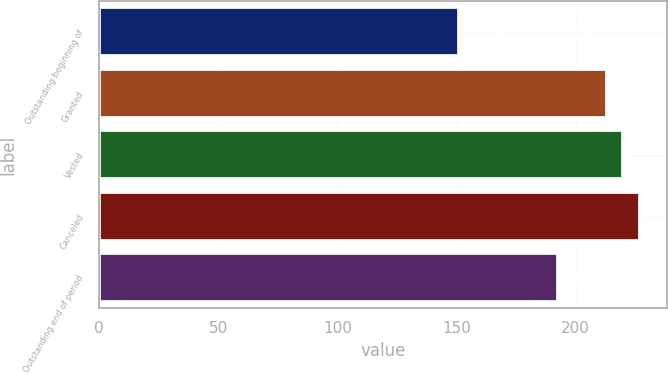Convert chart to OTSL. <chart><loc_0><loc_0><loc_500><loc_500><bar_chart><fcel>Outstanding beginning of<fcel>Granted<fcel>Vested<fcel>Canceled<fcel>Outstanding end of period<nl><fcel>150.96<fcel>213.09<fcel>219.99<fcel>226.89<fcel>192.41<nl></chart> 